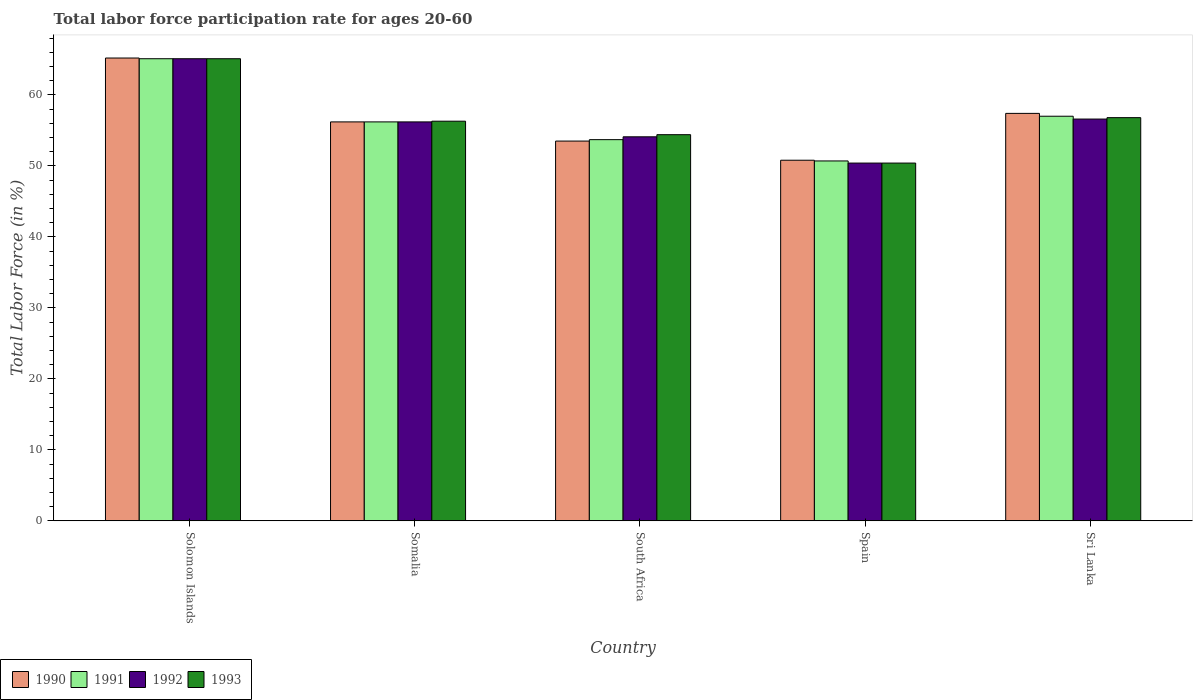What is the labor force participation rate in 1993 in South Africa?
Give a very brief answer. 54.4. Across all countries, what is the maximum labor force participation rate in 1993?
Your answer should be very brief. 65.1. Across all countries, what is the minimum labor force participation rate in 1991?
Provide a succinct answer. 50.7. In which country was the labor force participation rate in 1992 maximum?
Your answer should be very brief. Solomon Islands. What is the total labor force participation rate in 1991 in the graph?
Give a very brief answer. 282.7. What is the difference between the labor force participation rate in 1992 in Solomon Islands and that in South Africa?
Make the answer very short. 11. What is the difference between the labor force participation rate in 1991 in Somalia and the labor force participation rate in 1990 in Solomon Islands?
Give a very brief answer. -9. What is the average labor force participation rate in 1992 per country?
Your answer should be compact. 56.48. What is the difference between the labor force participation rate of/in 1993 and labor force participation rate of/in 1992 in Sri Lanka?
Your answer should be very brief. 0.2. In how many countries, is the labor force participation rate in 1993 greater than 8 %?
Your answer should be very brief. 5. What is the ratio of the labor force participation rate in 1993 in Spain to that in Sri Lanka?
Ensure brevity in your answer.  0.89. Is the labor force participation rate in 1993 in South Africa less than that in Sri Lanka?
Your response must be concise. Yes. Is the difference between the labor force participation rate in 1993 in South Africa and Sri Lanka greater than the difference between the labor force participation rate in 1992 in South Africa and Sri Lanka?
Provide a succinct answer. Yes. What is the difference between the highest and the second highest labor force participation rate in 1993?
Your answer should be very brief. -8.3. What is the difference between the highest and the lowest labor force participation rate in 1992?
Offer a very short reply. 14.7. Is the sum of the labor force participation rate in 1990 in South Africa and Spain greater than the maximum labor force participation rate in 1991 across all countries?
Your response must be concise. Yes. Is it the case that in every country, the sum of the labor force participation rate in 1991 and labor force participation rate in 1993 is greater than the labor force participation rate in 1990?
Ensure brevity in your answer.  Yes. How many bars are there?
Make the answer very short. 20. Are all the bars in the graph horizontal?
Provide a succinct answer. No. What is the title of the graph?
Ensure brevity in your answer.  Total labor force participation rate for ages 20-60. Does "1966" appear as one of the legend labels in the graph?
Your response must be concise. No. What is the label or title of the X-axis?
Give a very brief answer. Country. What is the label or title of the Y-axis?
Offer a terse response. Total Labor Force (in %). What is the Total Labor Force (in %) of 1990 in Solomon Islands?
Your answer should be compact. 65.2. What is the Total Labor Force (in %) of 1991 in Solomon Islands?
Your answer should be very brief. 65.1. What is the Total Labor Force (in %) of 1992 in Solomon Islands?
Ensure brevity in your answer.  65.1. What is the Total Labor Force (in %) of 1993 in Solomon Islands?
Your answer should be very brief. 65.1. What is the Total Labor Force (in %) of 1990 in Somalia?
Offer a very short reply. 56.2. What is the Total Labor Force (in %) in 1991 in Somalia?
Ensure brevity in your answer.  56.2. What is the Total Labor Force (in %) in 1992 in Somalia?
Your response must be concise. 56.2. What is the Total Labor Force (in %) in 1993 in Somalia?
Provide a short and direct response. 56.3. What is the Total Labor Force (in %) in 1990 in South Africa?
Provide a short and direct response. 53.5. What is the Total Labor Force (in %) in 1991 in South Africa?
Your answer should be compact. 53.7. What is the Total Labor Force (in %) of 1992 in South Africa?
Offer a terse response. 54.1. What is the Total Labor Force (in %) of 1993 in South Africa?
Give a very brief answer. 54.4. What is the Total Labor Force (in %) in 1990 in Spain?
Your answer should be very brief. 50.8. What is the Total Labor Force (in %) in 1991 in Spain?
Provide a succinct answer. 50.7. What is the Total Labor Force (in %) in 1992 in Spain?
Provide a short and direct response. 50.4. What is the Total Labor Force (in %) of 1993 in Spain?
Provide a succinct answer. 50.4. What is the Total Labor Force (in %) in 1990 in Sri Lanka?
Your answer should be compact. 57.4. What is the Total Labor Force (in %) in 1992 in Sri Lanka?
Provide a short and direct response. 56.6. What is the Total Labor Force (in %) in 1993 in Sri Lanka?
Give a very brief answer. 56.8. Across all countries, what is the maximum Total Labor Force (in %) of 1990?
Offer a terse response. 65.2. Across all countries, what is the maximum Total Labor Force (in %) in 1991?
Provide a short and direct response. 65.1. Across all countries, what is the maximum Total Labor Force (in %) in 1992?
Offer a terse response. 65.1. Across all countries, what is the maximum Total Labor Force (in %) of 1993?
Provide a succinct answer. 65.1. Across all countries, what is the minimum Total Labor Force (in %) of 1990?
Keep it short and to the point. 50.8. Across all countries, what is the minimum Total Labor Force (in %) in 1991?
Provide a short and direct response. 50.7. Across all countries, what is the minimum Total Labor Force (in %) in 1992?
Your response must be concise. 50.4. Across all countries, what is the minimum Total Labor Force (in %) of 1993?
Offer a very short reply. 50.4. What is the total Total Labor Force (in %) of 1990 in the graph?
Make the answer very short. 283.1. What is the total Total Labor Force (in %) of 1991 in the graph?
Your answer should be very brief. 282.7. What is the total Total Labor Force (in %) in 1992 in the graph?
Your answer should be compact. 282.4. What is the total Total Labor Force (in %) in 1993 in the graph?
Provide a succinct answer. 283. What is the difference between the Total Labor Force (in %) in 1990 in Solomon Islands and that in South Africa?
Offer a very short reply. 11.7. What is the difference between the Total Labor Force (in %) of 1992 in Solomon Islands and that in South Africa?
Provide a short and direct response. 11. What is the difference between the Total Labor Force (in %) of 1993 in Solomon Islands and that in South Africa?
Make the answer very short. 10.7. What is the difference between the Total Labor Force (in %) in 1993 in Solomon Islands and that in Spain?
Offer a terse response. 14.7. What is the difference between the Total Labor Force (in %) of 1991 in Solomon Islands and that in Sri Lanka?
Give a very brief answer. 8.1. What is the difference between the Total Labor Force (in %) of 1993 in Solomon Islands and that in Sri Lanka?
Provide a succinct answer. 8.3. What is the difference between the Total Labor Force (in %) in 1991 in Somalia and that in South Africa?
Your answer should be very brief. 2.5. What is the difference between the Total Labor Force (in %) in 1992 in Somalia and that in South Africa?
Offer a very short reply. 2.1. What is the difference between the Total Labor Force (in %) in 1990 in Somalia and that in Spain?
Provide a short and direct response. 5.4. What is the difference between the Total Labor Force (in %) of 1991 in Somalia and that in Spain?
Offer a very short reply. 5.5. What is the difference between the Total Labor Force (in %) of 1992 in Somalia and that in Spain?
Give a very brief answer. 5.8. What is the difference between the Total Labor Force (in %) of 1990 in Somalia and that in Sri Lanka?
Give a very brief answer. -1.2. What is the difference between the Total Labor Force (in %) of 1991 in Somalia and that in Sri Lanka?
Keep it short and to the point. -0.8. What is the difference between the Total Labor Force (in %) in 1990 in South Africa and that in Spain?
Offer a very short reply. 2.7. What is the difference between the Total Labor Force (in %) of 1991 in South Africa and that in Spain?
Provide a short and direct response. 3. What is the difference between the Total Labor Force (in %) in 1993 in South Africa and that in Spain?
Ensure brevity in your answer.  4. What is the difference between the Total Labor Force (in %) in 1990 in Spain and that in Sri Lanka?
Make the answer very short. -6.6. What is the difference between the Total Labor Force (in %) of 1991 in Spain and that in Sri Lanka?
Offer a very short reply. -6.3. What is the difference between the Total Labor Force (in %) of 1993 in Spain and that in Sri Lanka?
Provide a succinct answer. -6.4. What is the difference between the Total Labor Force (in %) of 1990 in Solomon Islands and the Total Labor Force (in %) of 1992 in Somalia?
Your answer should be compact. 9. What is the difference between the Total Labor Force (in %) in 1990 in Solomon Islands and the Total Labor Force (in %) in 1993 in Somalia?
Give a very brief answer. 8.9. What is the difference between the Total Labor Force (in %) of 1992 in Solomon Islands and the Total Labor Force (in %) of 1993 in Somalia?
Your answer should be very brief. 8.8. What is the difference between the Total Labor Force (in %) of 1990 in Solomon Islands and the Total Labor Force (in %) of 1992 in South Africa?
Your answer should be compact. 11.1. What is the difference between the Total Labor Force (in %) of 1991 in Solomon Islands and the Total Labor Force (in %) of 1992 in South Africa?
Provide a succinct answer. 11. What is the difference between the Total Labor Force (in %) of 1992 in Solomon Islands and the Total Labor Force (in %) of 1993 in South Africa?
Give a very brief answer. 10.7. What is the difference between the Total Labor Force (in %) in 1990 in Solomon Islands and the Total Labor Force (in %) in 1992 in Spain?
Keep it short and to the point. 14.8. What is the difference between the Total Labor Force (in %) of 1990 in Solomon Islands and the Total Labor Force (in %) of 1991 in Sri Lanka?
Ensure brevity in your answer.  8.2. What is the difference between the Total Labor Force (in %) in 1990 in Solomon Islands and the Total Labor Force (in %) in 1993 in Sri Lanka?
Your answer should be very brief. 8.4. What is the difference between the Total Labor Force (in %) in 1991 in Solomon Islands and the Total Labor Force (in %) in 1992 in Sri Lanka?
Make the answer very short. 8.5. What is the difference between the Total Labor Force (in %) in 1991 in Solomon Islands and the Total Labor Force (in %) in 1993 in Sri Lanka?
Your response must be concise. 8.3. What is the difference between the Total Labor Force (in %) in 1990 in Somalia and the Total Labor Force (in %) in 1993 in South Africa?
Make the answer very short. 1.8. What is the difference between the Total Labor Force (in %) in 1991 in Somalia and the Total Labor Force (in %) in 1992 in South Africa?
Give a very brief answer. 2.1. What is the difference between the Total Labor Force (in %) in 1991 in Somalia and the Total Labor Force (in %) in 1993 in South Africa?
Make the answer very short. 1.8. What is the difference between the Total Labor Force (in %) of 1992 in Somalia and the Total Labor Force (in %) of 1993 in South Africa?
Your response must be concise. 1.8. What is the difference between the Total Labor Force (in %) of 1990 in Somalia and the Total Labor Force (in %) of 1992 in Spain?
Make the answer very short. 5.8. What is the difference between the Total Labor Force (in %) in 1991 in Somalia and the Total Labor Force (in %) in 1992 in Spain?
Offer a terse response. 5.8. What is the difference between the Total Labor Force (in %) in 1992 in Somalia and the Total Labor Force (in %) in 1993 in Spain?
Your answer should be compact. 5.8. What is the difference between the Total Labor Force (in %) in 1990 in Somalia and the Total Labor Force (in %) in 1991 in Sri Lanka?
Provide a succinct answer. -0.8. What is the difference between the Total Labor Force (in %) in 1990 in Somalia and the Total Labor Force (in %) in 1992 in Sri Lanka?
Your response must be concise. -0.4. What is the difference between the Total Labor Force (in %) of 1991 in Somalia and the Total Labor Force (in %) of 1992 in Sri Lanka?
Provide a succinct answer. -0.4. What is the difference between the Total Labor Force (in %) in 1991 in Somalia and the Total Labor Force (in %) in 1993 in Sri Lanka?
Provide a succinct answer. -0.6. What is the difference between the Total Labor Force (in %) of 1992 in Somalia and the Total Labor Force (in %) of 1993 in Sri Lanka?
Make the answer very short. -0.6. What is the difference between the Total Labor Force (in %) in 1990 in South Africa and the Total Labor Force (in %) in 1992 in Spain?
Ensure brevity in your answer.  3.1. What is the difference between the Total Labor Force (in %) in 1990 in South Africa and the Total Labor Force (in %) in 1993 in Spain?
Offer a very short reply. 3.1. What is the difference between the Total Labor Force (in %) in 1991 in South Africa and the Total Labor Force (in %) in 1992 in Spain?
Your answer should be compact. 3.3. What is the difference between the Total Labor Force (in %) of 1992 in South Africa and the Total Labor Force (in %) of 1993 in Sri Lanka?
Provide a succinct answer. -2.7. What is the difference between the Total Labor Force (in %) in 1990 in Spain and the Total Labor Force (in %) in 1991 in Sri Lanka?
Provide a succinct answer. -6.2. What is the difference between the Total Labor Force (in %) in 1991 in Spain and the Total Labor Force (in %) in 1993 in Sri Lanka?
Make the answer very short. -6.1. What is the difference between the Total Labor Force (in %) of 1992 in Spain and the Total Labor Force (in %) of 1993 in Sri Lanka?
Provide a succinct answer. -6.4. What is the average Total Labor Force (in %) of 1990 per country?
Provide a short and direct response. 56.62. What is the average Total Labor Force (in %) in 1991 per country?
Provide a short and direct response. 56.54. What is the average Total Labor Force (in %) in 1992 per country?
Your response must be concise. 56.48. What is the average Total Labor Force (in %) in 1993 per country?
Offer a terse response. 56.6. What is the difference between the Total Labor Force (in %) in 1990 and Total Labor Force (in %) in 1991 in Solomon Islands?
Give a very brief answer. 0.1. What is the difference between the Total Labor Force (in %) of 1990 and Total Labor Force (in %) of 1992 in Solomon Islands?
Offer a very short reply. 0.1. What is the difference between the Total Labor Force (in %) in 1991 and Total Labor Force (in %) in 1992 in Solomon Islands?
Your response must be concise. 0. What is the difference between the Total Labor Force (in %) of 1991 and Total Labor Force (in %) of 1993 in Solomon Islands?
Provide a succinct answer. 0. What is the difference between the Total Labor Force (in %) of 1992 and Total Labor Force (in %) of 1993 in Solomon Islands?
Give a very brief answer. 0. What is the difference between the Total Labor Force (in %) in 1990 and Total Labor Force (in %) in 1992 in Somalia?
Make the answer very short. 0. What is the difference between the Total Labor Force (in %) of 1992 and Total Labor Force (in %) of 1993 in Somalia?
Ensure brevity in your answer.  -0.1. What is the difference between the Total Labor Force (in %) in 1990 and Total Labor Force (in %) in 1991 in South Africa?
Ensure brevity in your answer.  -0.2. What is the difference between the Total Labor Force (in %) in 1990 and Total Labor Force (in %) in 1993 in South Africa?
Make the answer very short. -0.9. What is the difference between the Total Labor Force (in %) of 1991 and Total Labor Force (in %) of 1992 in South Africa?
Give a very brief answer. -0.4. What is the difference between the Total Labor Force (in %) in 1991 and Total Labor Force (in %) in 1993 in South Africa?
Offer a very short reply. -0.7. What is the difference between the Total Labor Force (in %) of 1992 and Total Labor Force (in %) of 1993 in South Africa?
Offer a terse response. -0.3. What is the difference between the Total Labor Force (in %) of 1990 and Total Labor Force (in %) of 1991 in Spain?
Your answer should be very brief. 0.1. What is the difference between the Total Labor Force (in %) of 1990 and Total Labor Force (in %) of 1992 in Spain?
Give a very brief answer. 0.4. What is the difference between the Total Labor Force (in %) of 1990 and Total Labor Force (in %) of 1993 in Spain?
Your answer should be very brief. 0.4. What is the difference between the Total Labor Force (in %) of 1991 and Total Labor Force (in %) of 1992 in Spain?
Provide a succinct answer. 0.3. What is the difference between the Total Labor Force (in %) of 1990 and Total Labor Force (in %) of 1991 in Sri Lanka?
Keep it short and to the point. 0.4. What is the ratio of the Total Labor Force (in %) in 1990 in Solomon Islands to that in Somalia?
Provide a short and direct response. 1.16. What is the ratio of the Total Labor Force (in %) of 1991 in Solomon Islands to that in Somalia?
Keep it short and to the point. 1.16. What is the ratio of the Total Labor Force (in %) of 1992 in Solomon Islands to that in Somalia?
Your answer should be very brief. 1.16. What is the ratio of the Total Labor Force (in %) of 1993 in Solomon Islands to that in Somalia?
Ensure brevity in your answer.  1.16. What is the ratio of the Total Labor Force (in %) in 1990 in Solomon Islands to that in South Africa?
Make the answer very short. 1.22. What is the ratio of the Total Labor Force (in %) of 1991 in Solomon Islands to that in South Africa?
Your response must be concise. 1.21. What is the ratio of the Total Labor Force (in %) in 1992 in Solomon Islands to that in South Africa?
Your answer should be very brief. 1.2. What is the ratio of the Total Labor Force (in %) in 1993 in Solomon Islands to that in South Africa?
Offer a terse response. 1.2. What is the ratio of the Total Labor Force (in %) of 1990 in Solomon Islands to that in Spain?
Your answer should be very brief. 1.28. What is the ratio of the Total Labor Force (in %) in 1991 in Solomon Islands to that in Spain?
Offer a terse response. 1.28. What is the ratio of the Total Labor Force (in %) of 1992 in Solomon Islands to that in Spain?
Your response must be concise. 1.29. What is the ratio of the Total Labor Force (in %) of 1993 in Solomon Islands to that in Spain?
Keep it short and to the point. 1.29. What is the ratio of the Total Labor Force (in %) in 1990 in Solomon Islands to that in Sri Lanka?
Your answer should be very brief. 1.14. What is the ratio of the Total Labor Force (in %) in 1991 in Solomon Islands to that in Sri Lanka?
Give a very brief answer. 1.14. What is the ratio of the Total Labor Force (in %) in 1992 in Solomon Islands to that in Sri Lanka?
Offer a very short reply. 1.15. What is the ratio of the Total Labor Force (in %) in 1993 in Solomon Islands to that in Sri Lanka?
Your answer should be very brief. 1.15. What is the ratio of the Total Labor Force (in %) in 1990 in Somalia to that in South Africa?
Ensure brevity in your answer.  1.05. What is the ratio of the Total Labor Force (in %) in 1991 in Somalia to that in South Africa?
Your answer should be compact. 1.05. What is the ratio of the Total Labor Force (in %) in 1992 in Somalia to that in South Africa?
Your answer should be compact. 1.04. What is the ratio of the Total Labor Force (in %) in 1993 in Somalia to that in South Africa?
Your response must be concise. 1.03. What is the ratio of the Total Labor Force (in %) of 1990 in Somalia to that in Spain?
Provide a short and direct response. 1.11. What is the ratio of the Total Labor Force (in %) in 1991 in Somalia to that in Spain?
Your answer should be compact. 1.11. What is the ratio of the Total Labor Force (in %) of 1992 in Somalia to that in Spain?
Ensure brevity in your answer.  1.12. What is the ratio of the Total Labor Force (in %) in 1993 in Somalia to that in Spain?
Give a very brief answer. 1.12. What is the ratio of the Total Labor Force (in %) of 1990 in Somalia to that in Sri Lanka?
Offer a terse response. 0.98. What is the ratio of the Total Labor Force (in %) of 1991 in Somalia to that in Sri Lanka?
Provide a short and direct response. 0.99. What is the ratio of the Total Labor Force (in %) of 1992 in Somalia to that in Sri Lanka?
Provide a short and direct response. 0.99. What is the ratio of the Total Labor Force (in %) in 1993 in Somalia to that in Sri Lanka?
Offer a terse response. 0.99. What is the ratio of the Total Labor Force (in %) in 1990 in South Africa to that in Spain?
Give a very brief answer. 1.05. What is the ratio of the Total Labor Force (in %) in 1991 in South Africa to that in Spain?
Your answer should be compact. 1.06. What is the ratio of the Total Labor Force (in %) in 1992 in South Africa to that in Spain?
Your answer should be very brief. 1.07. What is the ratio of the Total Labor Force (in %) of 1993 in South Africa to that in Spain?
Make the answer very short. 1.08. What is the ratio of the Total Labor Force (in %) of 1990 in South Africa to that in Sri Lanka?
Your response must be concise. 0.93. What is the ratio of the Total Labor Force (in %) in 1991 in South Africa to that in Sri Lanka?
Keep it short and to the point. 0.94. What is the ratio of the Total Labor Force (in %) in 1992 in South Africa to that in Sri Lanka?
Provide a succinct answer. 0.96. What is the ratio of the Total Labor Force (in %) in 1993 in South Africa to that in Sri Lanka?
Your answer should be compact. 0.96. What is the ratio of the Total Labor Force (in %) in 1990 in Spain to that in Sri Lanka?
Make the answer very short. 0.89. What is the ratio of the Total Labor Force (in %) of 1991 in Spain to that in Sri Lanka?
Offer a very short reply. 0.89. What is the ratio of the Total Labor Force (in %) of 1992 in Spain to that in Sri Lanka?
Your answer should be compact. 0.89. What is the ratio of the Total Labor Force (in %) of 1993 in Spain to that in Sri Lanka?
Your answer should be very brief. 0.89. What is the difference between the highest and the second highest Total Labor Force (in %) of 1992?
Offer a very short reply. 8.5. 